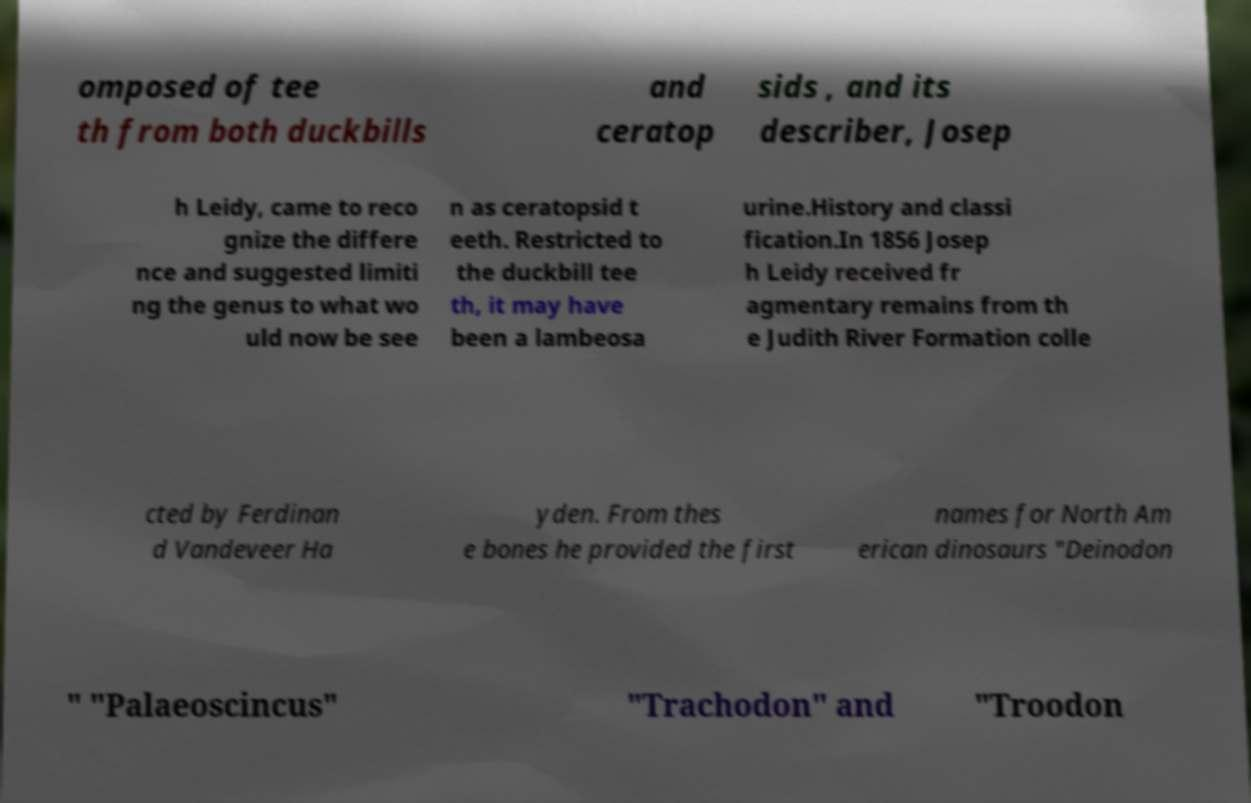There's text embedded in this image that I need extracted. Can you transcribe it verbatim? omposed of tee th from both duckbills and ceratop sids , and its describer, Josep h Leidy, came to reco gnize the differe nce and suggested limiti ng the genus to what wo uld now be see n as ceratopsid t eeth. Restricted to the duckbill tee th, it may have been a lambeosa urine.History and classi fication.In 1856 Josep h Leidy received fr agmentary remains from th e Judith River Formation colle cted by Ferdinan d Vandeveer Ha yden. From thes e bones he provided the first names for North Am erican dinosaurs "Deinodon " "Palaeoscincus" "Trachodon" and "Troodon 